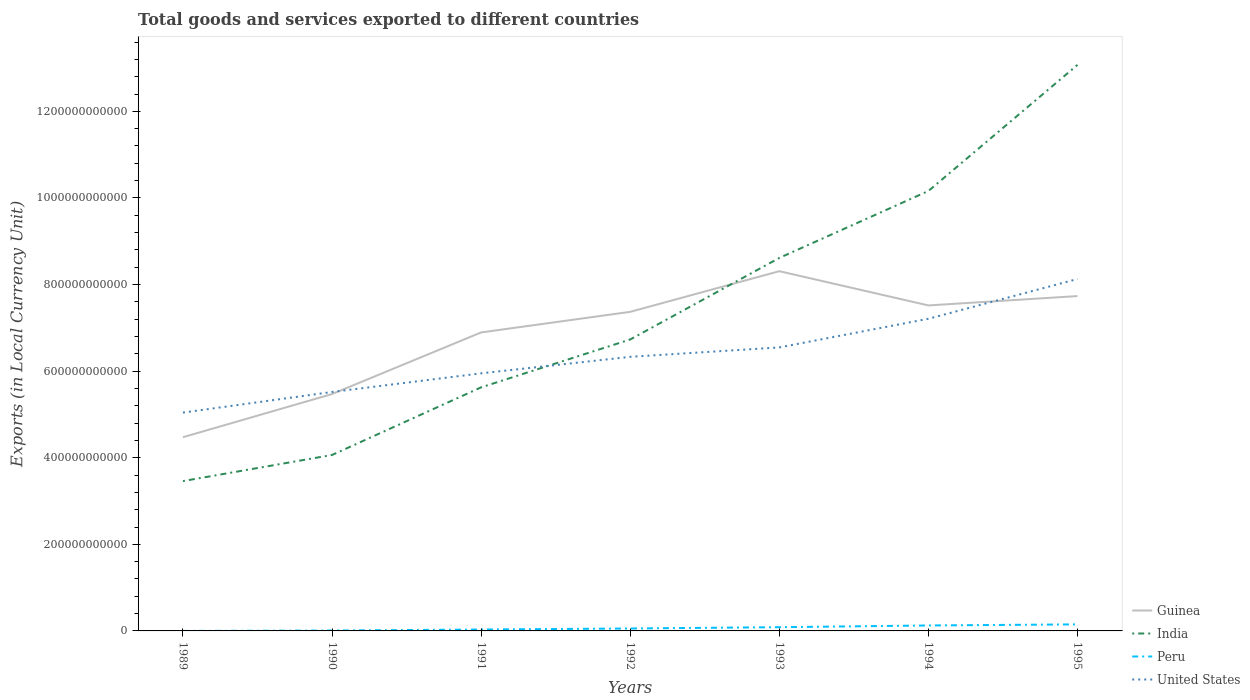How many different coloured lines are there?
Provide a short and direct response. 4. Does the line corresponding to United States intersect with the line corresponding to India?
Offer a very short reply. Yes. Is the number of lines equal to the number of legend labels?
Make the answer very short. Yes. Across all years, what is the maximum Amount of goods and services exports in Guinea?
Offer a terse response. 4.47e+11. What is the total Amount of goods and services exports in Guinea in the graph?
Offer a terse response. -2.26e+11. What is the difference between the highest and the second highest Amount of goods and services exports in India?
Ensure brevity in your answer.  9.61e+11. What is the difference between the highest and the lowest Amount of goods and services exports in Guinea?
Provide a short and direct response. 5. How many lines are there?
Your answer should be very brief. 4. What is the difference between two consecutive major ticks on the Y-axis?
Your answer should be compact. 2.00e+11. How are the legend labels stacked?
Your answer should be very brief. Vertical. What is the title of the graph?
Offer a very short reply. Total goods and services exported to different countries. What is the label or title of the Y-axis?
Provide a succinct answer. Exports (in Local Currency Unit). What is the Exports (in Local Currency Unit) of Guinea in 1989?
Your response must be concise. 4.47e+11. What is the Exports (in Local Currency Unit) of India in 1989?
Your response must be concise. 3.46e+11. What is the Exports (in Local Currency Unit) in Peru in 1989?
Provide a short and direct response. 1.57e+07. What is the Exports (in Local Currency Unit) of United States in 1989?
Your answer should be compact. 5.04e+11. What is the Exports (in Local Currency Unit) in Guinea in 1990?
Provide a short and direct response. 5.47e+11. What is the Exports (in Local Currency Unit) of India in 1990?
Your response must be concise. 4.06e+11. What is the Exports (in Local Currency Unit) of Peru in 1990?
Ensure brevity in your answer.  8.58e+08. What is the Exports (in Local Currency Unit) of United States in 1990?
Give a very brief answer. 5.52e+11. What is the Exports (in Local Currency Unit) of Guinea in 1991?
Your answer should be very brief. 6.89e+11. What is the Exports (in Local Currency Unit) in India in 1991?
Give a very brief answer. 5.63e+11. What is the Exports (in Local Currency Unit) in Peru in 1991?
Your response must be concise. 3.26e+09. What is the Exports (in Local Currency Unit) of United States in 1991?
Keep it short and to the point. 5.95e+11. What is the Exports (in Local Currency Unit) in Guinea in 1992?
Your answer should be compact. 7.37e+11. What is the Exports (in Local Currency Unit) of India in 1992?
Your answer should be compact. 6.73e+11. What is the Exports (in Local Currency Unit) in Peru in 1992?
Give a very brief answer. 5.63e+09. What is the Exports (in Local Currency Unit) in United States in 1992?
Offer a very short reply. 6.33e+11. What is the Exports (in Local Currency Unit) in Guinea in 1993?
Ensure brevity in your answer.  8.31e+11. What is the Exports (in Local Currency Unit) in India in 1993?
Offer a terse response. 8.61e+11. What is the Exports (in Local Currency Unit) in Peru in 1993?
Make the answer very short. 8.63e+09. What is the Exports (in Local Currency Unit) in United States in 1993?
Keep it short and to the point. 6.55e+11. What is the Exports (in Local Currency Unit) of Guinea in 1994?
Offer a terse response. 7.52e+11. What is the Exports (in Local Currency Unit) of India in 1994?
Provide a short and direct response. 1.02e+12. What is the Exports (in Local Currency Unit) of Peru in 1994?
Offer a very short reply. 1.26e+1. What is the Exports (in Local Currency Unit) in United States in 1994?
Make the answer very short. 7.21e+11. What is the Exports (in Local Currency Unit) of Guinea in 1995?
Your response must be concise. 7.73e+11. What is the Exports (in Local Currency Unit) in India in 1995?
Offer a very short reply. 1.31e+12. What is the Exports (in Local Currency Unit) of Peru in 1995?
Give a very brief answer. 1.51e+1. What is the Exports (in Local Currency Unit) of United States in 1995?
Provide a short and direct response. 8.13e+11. Across all years, what is the maximum Exports (in Local Currency Unit) in Guinea?
Your answer should be very brief. 8.31e+11. Across all years, what is the maximum Exports (in Local Currency Unit) of India?
Keep it short and to the point. 1.31e+12. Across all years, what is the maximum Exports (in Local Currency Unit) of Peru?
Your answer should be compact. 1.51e+1. Across all years, what is the maximum Exports (in Local Currency Unit) of United States?
Your answer should be very brief. 8.13e+11. Across all years, what is the minimum Exports (in Local Currency Unit) of Guinea?
Provide a short and direct response. 4.47e+11. Across all years, what is the minimum Exports (in Local Currency Unit) in India?
Provide a short and direct response. 3.46e+11. Across all years, what is the minimum Exports (in Local Currency Unit) in Peru?
Your answer should be compact. 1.57e+07. Across all years, what is the minimum Exports (in Local Currency Unit) of United States?
Your answer should be very brief. 5.04e+11. What is the total Exports (in Local Currency Unit) of Guinea in the graph?
Give a very brief answer. 4.78e+12. What is the total Exports (in Local Currency Unit) in India in the graph?
Provide a short and direct response. 5.17e+12. What is the total Exports (in Local Currency Unit) of Peru in the graph?
Your answer should be compact. 4.61e+1. What is the total Exports (in Local Currency Unit) in United States in the graph?
Provide a succinct answer. 4.47e+12. What is the difference between the Exports (in Local Currency Unit) in Guinea in 1989 and that in 1990?
Make the answer very short. -9.97e+1. What is the difference between the Exports (in Local Currency Unit) of India in 1989 and that in 1990?
Your response must be concise. -6.03e+1. What is the difference between the Exports (in Local Currency Unit) of Peru in 1989 and that in 1990?
Offer a terse response. -8.42e+08. What is the difference between the Exports (in Local Currency Unit) in United States in 1989 and that in 1990?
Provide a succinct answer. -4.76e+1. What is the difference between the Exports (in Local Currency Unit) of Guinea in 1989 and that in 1991?
Provide a short and direct response. -2.42e+11. What is the difference between the Exports (in Local Currency Unit) in India in 1989 and that in 1991?
Your response must be concise. -2.16e+11. What is the difference between the Exports (in Local Currency Unit) of Peru in 1989 and that in 1991?
Give a very brief answer. -3.24e+09. What is the difference between the Exports (in Local Currency Unit) in United States in 1989 and that in 1991?
Your answer should be compact. -9.06e+1. What is the difference between the Exports (in Local Currency Unit) of Guinea in 1989 and that in 1992?
Give a very brief answer. -2.90e+11. What is the difference between the Exports (in Local Currency Unit) in India in 1989 and that in 1992?
Make the answer very short. -3.27e+11. What is the difference between the Exports (in Local Currency Unit) in Peru in 1989 and that in 1992?
Make the answer very short. -5.61e+09. What is the difference between the Exports (in Local Currency Unit) in United States in 1989 and that in 1992?
Ensure brevity in your answer.  -1.29e+11. What is the difference between the Exports (in Local Currency Unit) in Guinea in 1989 and that in 1993?
Your response must be concise. -3.83e+11. What is the difference between the Exports (in Local Currency Unit) in India in 1989 and that in 1993?
Offer a very short reply. -5.15e+11. What is the difference between the Exports (in Local Currency Unit) in Peru in 1989 and that in 1993?
Ensure brevity in your answer.  -8.61e+09. What is the difference between the Exports (in Local Currency Unit) in United States in 1989 and that in 1993?
Make the answer very short. -1.51e+11. What is the difference between the Exports (in Local Currency Unit) in Guinea in 1989 and that in 1994?
Ensure brevity in your answer.  -3.04e+11. What is the difference between the Exports (in Local Currency Unit) of India in 1989 and that in 1994?
Ensure brevity in your answer.  -6.70e+11. What is the difference between the Exports (in Local Currency Unit) in Peru in 1989 and that in 1994?
Keep it short and to the point. -1.26e+1. What is the difference between the Exports (in Local Currency Unit) in United States in 1989 and that in 1994?
Offer a terse response. -2.17e+11. What is the difference between the Exports (in Local Currency Unit) in Guinea in 1989 and that in 1995?
Give a very brief answer. -3.26e+11. What is the difference between the Exports (in Local Currency Unit) of India in 1989 and that in 1995?
Keep it short and to the point. -9.61e+11. What is the difference between the Exports (in Local Currency Unit) in Peru in 1989 and that in 1995?
Ensure brevity in your answer.  -1.51e+1. What is the difference between the Exports (in Local Currency Unit) in United States in 1989 and that in 1995?
Ensure brevity in your answer.  -3.09e+11. What is the difference between the Exports (in Local Currency Unit) in Guinea in 1990 and that in 1991?
Ensure brevity in your answer.  -1.42e+11. What is the difference between the Exports (in Local Currency Unit) in India in 1990 and that in 1991?
Provide a short and direct response. -1.56e+11. What is the difference between the Exports (in Local Currency Unit) in Peru in 1990 and that in 1991?
Your answer should be very brief. -2.40e+09. What is the difference between the Exports (in Local Currency Unit) of United States in 1990 and that in 1991?
Ensure brevity in your answer.  -4.31e+1. What is the difference between the Exports (in Local Currency Unit) of Guinea in 1990 and that in 1992?
Provide a succinct answer. -1.90e+11. What is the difference between the Exports (in Local Currency Unit) of India in 1990 and that in 1992?
Offer a terse response. -2.67e+11. What is the difference between the Exports (in Local Currency Unit) in Peru in 1990 and that in 1992?
Ensure brevity in your answer.  -4.77e+09. What is the difference between the Exports (in Local Currency Unit) of United States in 1990 and that in 1992?
Make the answer very short. -8.12e+1. What is the difference between the Exports (in Local Currency Unit) of Guinea in 1990 and that in 1993?
Keep it short and to the point. -2.84e+11. What is the difference between the Exports (in Local Currency Unit) in India in 1990 and that in 1993?
Your answer should be very brief. -4.55e+11. What is the difference between the Exports (in Local Currency Unit) in Peru in 1990 and that in 1993?
Your answer should be compact. -7.77e+09. What is the difference between the Exports (in Local Currency Unit) of United States in 1990 and that in 1993?
Provide a short and direct response. -1.03e+11. What is the difference between the Exports (in Local Currency Unit) of Guinea in 1990 and that in 1994?
Give a very brief answer. -2.05e+11. What is the difference between the Exports (in Local Currency Unit) in India in 1990 and that in 1994?
Your answer should be compact. -6.10e+11. What is the difference between the Exports (in Local Currency Unit) in Peru in 1990 and that in 1994?
Provide a succinct answer. -1.17e+1. What is the difference between the Exports (in Local Currency Unit) in United States in 1990 and that in 1994?
Offer a terse response. -1.69e+11. What is the difference between the Exports (in Local Currency Unit) of Guinea in 1990 and that in 1995?
Provide a succinct answer. -2.26e+11. What is the difference between the Exports (in Local Currency Unit) of India in 1990 and that in 1995?
Your response must be concise. -9.01e+11. What is the difference between the Exports (in Local Currency Unit) of Peru in 1990 and that in 1995?
Your response must be concise. -1.43e+1. What is the difference between the Exports (in Local Currency Unit) in United States in 1990 and that in 1995?
Your response must be concise. -2.61e+11. What is the difference between the Exports (in Local Currency Unit) of Guinea in 1991 and that in 1992?
Your answer should be very brief. -4.76e+1. What is the difference between the Exports (in Local Currency Unit) in India in 1991 and that in 1992?
Give a very brief answer. -1.11e+11. What is the difference between the Exports (in Local Currency Unit) in Peru in 1991 and that in 1992?
Your response must be concise. -2.37e+09. What is the difference between the Exports (in Local Currency Unit) of United States in 1991 and that in 1992?
Give a very brief answer. -3.81e+1. What is the difference between the Exports (in Local Currency Unit) of Guinea in 1991 and that in 1993?
Give a very brief answer. -1.41e+11. What is the difference between the Exports (in Local Currency Unit) in India in 1991 and that in 1993?
Keep it short and to the point. -2.99e+11. What is the difference between the Exports (in Local Currency Unit) of Peru in 1991 and that in 1993?
Give a very brief answer. -5.37e+09. What is the difference between the Exports (in Local Currency Unit) of United States in 1991 and that in 1993?
Make the answer very short. -5.99e+1. What is the difference between the Exports (in Local Currency Unit) in Guinea in 1991 and that in 1994?
Make the answer very short. -6.24e+1. What is the difference between the Exports (in Local Currency Unit) in India in 1991 and that in 1994?
Your answer should be compact. -4.54e+11. What is the difference between the Exports (in Local Currency Unit) in Peru in 1991 and that in 1994?
Your answer should be very brief. -9.33e+09. What is the difference between the Exports (in Local Currency Unit) in United States in 1991 and that in 1994?
Provide a short and direct response. -1.26e+11. What is the difference between the Exports (in Local Currency Unit) in Guinea in 1991 and that in 1995?
Keep it short and to the point. -8.40e+1. What is the difference between the Exports (in Local Currency Unit) of India in 1991 and that in 1995?
Offer a terse response. -7.45e+11. What is the difference between the Exports (in Local Currency Unit) of Peru in 1991 and that in 1995?
Keep it short and to the point. -1.19e+1. What is the difference between the Exports (in Local Currency Unit) of United States in 1991 and that in 1995?
Your answer should be compact. -2.18e+11. What is the difference between the Exports (in Local Currency Unit) in Guinea in 1992 and that in 1993?
Your answer should be compact. -9.39e+1. What is the difference between the Exports (in Local Currency Unit) in India in 1992 and that in 1993?
Your response must be concise. -1.88e+11. What is the difference between the Exports (in Local Currency Unit) of Peru in 1992 and that in 1993?
Your answer should be very brief. -3.00e+09. What is the difference between the Exports (in Local Currency Unit) in United States in 1992 and that in 1993?
Ensure brevity in your answer.  -2.17e+1. What is the difference between the Exports (in Local Currency Unit) of Guinea in 1992 and that in 1994?
Your response must be concise. -1.48e+1. What is the difference between the Exports (in Local Currency Unit) in India in 1992 and that in 1994?
Provide a succinct answer. -3.43e+11. What is the difference between the Exports (in Local Currency Unit) of Peru in 1992 and that in 1994?
Offer a very short reply. -6.96e+09. What is the difference between the Exports (in Local Currency Unit) of United States in 1992 and that in 1994?
Make the answer very short. -8.79e+1. What is the difference between the Exports (in Local Currency Unit) in Guinea in 1992 and that in 1995?
Provide a succinct answer. -3.64e+1. What is the difference between the Exports (in Local Currency Unit) in India in 1992 and that in 1995?
Your answer should be compact. -6.34e+11. What is the difference between the Exports (in Local Currency Unit) in Peru in 1992 and that in 1995?
Provide a short and direct response. -9.49e+09. What is the difference between the Exports (in Local Currency Unit) in United States in 1992 and that in 1995?
Give a very brief answer. -1.80e+11. What is the difference between the Exports (in Local Currency Unit) in Guinea in 1993 and that in 1994?
Make the answer very short. 7.91e+1. What is the difference between the Exports (in Local Currency Unit) of India in 1993 and that in 1994?
Ensure brevity in your answer.  -1.55e+11. What is the difference between the Exports (in Local Currency Unit) in Peru in 1993 and that in 1994?
Your answer should be compact. -3.96e+09. What is the difference between the Exports (in Local Currency Unit) of United States in 1993 and that in 1994?
Your answer should be compact. -6.61e+1. What is the difference between the Exports (in Local Currency Unit) in Guinea in 1993 and that in 1995?
Provide a short and direct response. 5.75e+1. What is the difference between the Exports (in Local Currency Unit) in India in 1993 and that in 1995?
Your answer should be compact. -4.46e+11. What is the difference between the Exports (in Local Currency Unit) of Peru in 1993 and that in 1995?
Provide a short and direct response. -6.49e+09. What is the difference between the Exports (in Local Currency Unit) of United States in 1993 and that in 1995?
Your response must be concise. -1.58e+11. What is the difference between the Exports (in Local Currency Unit) in Guinea in 1994 and that in 1995?
Provide a succinct answer. -2.16e+1. What is the difference between the Exports (in Local Currency Unit) in India in 1994 and that in 1995?
Offer a terse response. -2.91e+11. What is the difference between the Exports (in Local Currency Unit) in Peru in 1994 and that in 1995?
Ensure brevity in your answer.  -2.53e+09. What is the difference between the Exports (in Local Currency Unit) in United States in 1994 and that in 1995?
Ensure brevity in your answer.  -9.19e+1. What is the difference between the Exports (in Local Currency Unit) in Guinea in 1989 and the Exports (in Local Currency Unit) in India in 1990?
Provide a short and direct response. 4.11e+1. What is the difference between the Exports (in Local Currency Unit) in Guinea in 1989 and the Exports (in Local Currency Unit) in Peru in 1990?
Make the answer very short. 4.47e+11. What is the difference between the Exports (in Local Currency Unit) of Guinea in 1989 and the Exports (in Local Currency Unit) of United States in 1990?
Offer a very short reply. -1.04e+11. What is the difference between the Exports (in Local Currency Unit) of India in 1989 and the Exports (in Local Currency Unit) of Peru in 1990?
Ensure brevity in your answer.  3.45e+11. What is the difference between the Exports (in Local Currency Unit) in India in 1989 and the Exports (in Local Currency Unit) in United States in 1990?
Ensure brevity in your answer.  -2.06e+11. What is the difference between the Exports (in Local Currency Unit) of Peru in 1989 and the Exports (in Local Currency Unit) of United States in 1990?
Offer a terse response. -5.52e+11. What is the difference between the Exports (in Local Currency Unit) in Guinea in 1989 and the Exports (in Local Currency Unit) in India in 1991?
Your answer should be compact. -1.15e+11. What is the difference between the Exports (in Local Currency Unit) of Guinea in 1989 and the Exports (in Local Currency Unit) of Peru in 1991?
Your response must be concise. 4.44e+11. What is the difference between the Exports (in Local Currency Unit) of Guinea in 1989 and the Exports (in Local Currency Unit) of United States in 1991?
Your response must be concise. -1.48e+11. What is the difference between the Exports (in Local Currency Unit) of India in 1989 and the Exports (in Local Currency Unit) of Peru in 1991?
Make the answer very short. 3.43e+11. What is the difference between the Exports (in Local Currency Unit) in India in 1989 and the Exports (in Local Currency Unit) in United States in 1991?
Offer a terse response. -2.49e+11. What is the difference between the Exports (in Local Currency Unit) of Peru in 1989 and the Exports (in Local Currency Unit) of United States in 1991?
Ensure brevity in your answer.  -5.95e+11. What is the difference between the Exports (in Local Currency Unit) of Guinea in 1989 and the Exports (in Local Currency Unit) of India in 1992?
Your answer should be compact. -2.26e+11. What is the difference between the Exports (in Local Currency Unit) of Guinea in 1989 and the Exports (in Local Currency Unit) of Peru in 1992?
Ensure brevity in your answer.  4.42e+11. What is the difference between the Exports (in Local Currency Unit) in Guinea in 1989 and the Exports (in Local Currency Unit) in United States in 1992?
Your answer should be very brief. -1.86e+11. What is the difference between the Exports (in Local Currency Unit) in India in 1989 and the Exports (in Local Currency Unit) in Peru in 1992?
Your answer should be very brief. 3.40e+11. What is the difference between the Exports (in Local Currency Unit) in India in 1989 and the Exports (in Local Currency Unit) in United States in 1992?
Offer a terse response. -2.87e+11. What is the difference between the Exports (in Local Currency Unit) of Peru in 1989 and the Exports (in Local Currency Unit) of United States in 1992?
Your response must be concise. -6.33e+11. What is the difference between the Exports (in Local Currency Unit) of Guinea in 1989 and the Exports (in Local Currency Unit) of India in 1993?
Provide a succinct answer. -4.14e+11. What is the difference between the Exports (in Local Currency Unit) of Guinea in 1989 and the Exports (in Local Currency Unit) of Peru in 1993?
Your answer should be compact. 4.39e+11. What is the difference between the Exports (in Local Currency Unit) of Guinea in 1989 and the Exports (in Local Currency Unit) of United States in 1993?
Your answer should be very brief. -2.07e+11. What is the difference between the Exports (in Local Currency Unit) in India in 1989 and the Exports (in Local Currency Unit) in Peru in 1993?
Offer a terse response. 3.37e+11. What is the difference between the Exports (in Local Currency Unit) in India in 1989 and the Exports (in Local Currency Unit) in United States in 1993?
Keep it short and to the point. -3.09e+11. What is the difference between the Exports (in Local Currency Unit) of Peru in 1989 and the Exports (in Local Currency Unit) of United States in 1993?
Ensure brevity in your answer.  -6.55e+11. What is the difference between the Exports (in Local Currency Unit) of Guinea in 1989 and the Exports (in Local Currency Unit) of India in 1994?
Keep it short and to the point. -5.69e+11. What is the difference between the Exports (in Local Currency Unit) of Guinea in 1989 and the Exports (in Local Currency Unit) of Peru in 1994?
Provide a succinct answer. 4.35e+11. What is the difference between the Exports (in Local Currency Unit) in Guinea in 1989 and the Exports (in Local Currency Unit) in United States in 1994?
Provide a short and direct response. -2.74e+11. What is the difference between the Exports (in Local Currency Unit) of India in 1989 and the Exports (in Local Currency Unit) of Peru in 1994?
Provide a short and direct response. 3.33e+11. What is the difference between the Exports (in Local Currency Unit) of India in 1989 and the Exports (in Local Currency Unit) of United States in 1994?
Give a very brief answer. -3.75e+11. What is the difference between the Exports (in Local Currency Unit) of Peru in 1989 and the Exports (in Local Currency Unit) of United States in 1994?
Your answer should be very brief. -7.21e+11. What is the difference between the Exports (in Local Currency Unit) in Guinea in 1989 and the Exports (in Local Currency Unit) in India in 1995?
Provide a short and direct response. -8.60e+11. What is the difference between the Exports (in Local Currency Unit) in Guinea in 1989 and the Exports (in Local Currency Unit) in Peru in 1995?
Ensure brevity in your answer.  4.32e+11. What is the difference between the Exports (in Local Currency Unit) in Guinea in 1989 and the Exports (in Local Currency Unit) in United States in 1995?
Offer a terse response. -3.65e+11. What is the difference between the Exports (in Local Currency Unit) of India in 1989 and the Exports (in Local Currency Unit) of Peru in 1995?
Your response must be concise. 3.31e+11. What is the difference between the Exports (in Local Currency Unit) in India in 1989 and the Exports (in Local Currency Unit) in United States in 1995?
Provide a succinct answer. -4.67e+11. What is the difference between the Exports (in Local Currency Unit) of Peru in 1989 and the Exports (in Local Currency Unit) of United States in 1995?
Give a very brief answer. -8.13e+11. What is the difference between the Exports (in Local Currency Unit) of Guinea in 1990 and the Exports (in Local Currency Unit) of India in 1991?
Keep it short and to the point. -1.55e+1. What is the difference between the Exports (in Local Currency Unit) of Guinea in 1990 and the Exports (in Local Currency Unit) of Peru in 1991?
Provide a succinct answer. 5.44e+11. What is the difference between the Exports (in Local Currency Unit) of Guinea in 1990 and the Exports (in Local Currency Unit) of United States in 1991?
Provide a succinct answer. -4.79e+1. What is the difference between the Exports (in Local Currency Unit) of India in 1990 and the Exports (in Local Currency Unit) of Peru in 1991?
Provide a succinct answer. 4.03e+11. What is the difference between the Exports (in Local Currency Unit) in India in 1990 and the Exports (in Local Currency Unit) in United States in 1991?
Offer a terse response. -1.89e+11. What is the difference between the Exports (in Local Currency Unit) in Peru in 1990 and the Exports (in Local Currency Unit) in United States in 1991?
Keep it short and to the point. -5.94e+11. What is the difference between the Exports (in Local Currency Unit) of Guinea in 1990 and the Exports (in Local Currency Unit) of India in 1992?
Give a very brief answer. -1.26e+11. What is the difference between the Exports (in Local Currency Unit) in Guinea in 1990 and the Exports (in Local Currency Unit) in Peru in 1992?
Make the answer very short. 5.41e+11. What is the difference between the Exports (in Local Currency Unit) in Guinea in 1990 and the Exports (in Local Currency Unit) in United States in 1992?
Offer a terse response. -8.60e+1. What is the difference between the Exports (in Local Currency Unit) in India in 1990 and the Exports (in Local Currency Unit) in Peru in 1992?
Ensure brevity in your answer.  4.01e+11. What is the difference between the Exports (in Local Currency Unit) of India in 1990 and the Exports (in Local Currency Unit) of United States in 1992?
Your answer should be compact. -2.27e+11. What is the difference between the Exports (in Local Currency Unit) of Peru in 1990 and the Exports (in Local Currency Unit) of United States in 1992?
Provide a short and direct response. -6.32e+11. What is the difference between the Exports (in Local Currency Unit) in Guinea in 1990 and the Exports (in Local Currency Unit) in India in 1993?
Keep it short and to the point. -3.14e+11. What is the difference between the Exports (in Local Currency Unit) in Guinea in 1990 and the Exports (in Local Currency Unit) in Peru in 1993?
Make the answer very short. 5.38e+11. What is the difference between the Exports (in Local Currency Unit) of Guinea in 1990 and the Exports (in Local Currency Unit) of United States in 1993?
Provide a short and direct response. -1.08e+11. What is the difference between the Exports (in Local Currency Unit) in India in 1990 and the Exports (in Local Currency Unit) in Peru in 1993?
Keep it short and to the point. 3.98e+11. What is the difference between the Exports (in Local Currency Unit) in India in 1990 and the Exports (in Local Currency Unit) in United States in 1993?
Keep it short and to the point. -2.48e+11. What is the difference between the Exports (in Local Currency Unit) of Peru in 1990 and the Exports (in Local Currency Unit) of United States in 1993?
Provide a succinct answer. -6.54e+11. What is the difference between the Exports (in Local Currency Unit) in Guinea in 1990 and the Exports (in Local Currency Unit) in India in 1994?
Your answer should be compact. -4.69e+11. What is the difference between the Exports (in Local Currency Unit) in Guinea in 1990 and the Exports (in Local Currency Unit) in Peru in 1994?
Your answer should be compact. 5.34e+11. What is the difference between the Exports (in Local Currency Unit) in Guinea in 1990 and the Exports (in Local Currency Unit) in United States in 1994?
Offer a very short reply. -1.74e+11. What is the difference between the Exports (in Local Currency Unit) in India in 1990 and the Exports (in Local Currency Unit) in Peru in 1994?
Give a very brief answer. 3.94e+11. What is the difference between the Exports (in Local Currency Unit) in India in 1990 and the Exports (in Local Currency Unit) in United States in 1994?
Give a very brief answer. -3.15e+11. What is the difference between the Exports (in Local Currency Unit) in Peru in 1990 and the Exports (in Local Currency Unit) in United States in 1994?
Give a very brief answer. -7.20e+11. What is the difference between the Exports (in Local Currency Unit) of Guinea in 1990 and the Exports (in Local Currency Unit) of India in 1995?
Provide a short and direct response. -7.60e+11. What is the difference between the Exports (in Local Currency Unit) of Guinea in 1990 and the Exports (in Local Currency Unit) of Peru in 1995?
Give a very brief answer. 5.32e+11. What is the difference between the Exports (in Local Currency Unit) in Guinea in 1990 and the Exports (in Local Currency Unit) in United States in 1995?
Make the answer very short. -2.66e+11. What is the difference between the Exports (in Local Currency Unit) in India in 1990 and the Exports (in Local Currency Unit) in Peru in 1995?
Your response must be concise. 3.91e+11. What is the difference between the Exports (in Local Currency Unit) of India in 1990 and the Exports (in Local Currency Unit) of United States in 1995?
Provide a succinct answer. -4.06e+11. What is the difference between the Exports (in Local Currency Unit) in Peru in 1990 and the Exports (in Local Currency Unit) in United States in 1995?
Your answer should be very brief. -8.12e+11. What is the difference between the Exports (in Local Currency Unit) of Guinea in 1991 and the Exports (in Local Currency Unit) of India in 1992?
Offer a terse response. 1.63e+1. What is the difference between the Exports (in Local Currency Unit) of Guinea in 1991 and the Exports (in Local Currency Unit) of Peru in 1992?
Your answer should be compact. 6.84e+11. What is the difference between the Exports (in Local Currency Unit) in Guinea in 1991 and the Exports (in Local Currency Unit) in United States in 1992?
Your answer should be very brief. 5.63e+1. What is the difference between the Exports (in Local Currency Unit) in India in 1991 and the Exports (in Local Currency Unit) in Peru in 1992?
Give a very brief answer. 5.57e+11. What is the difference between the Exports (in Local Currency Unit) in India in 1991 and the Exports (in Local Currency Unit) in United States in 1992?
Offer a very short reply. -7.05e+1. What is the difference between the Exports (in Local Currency Unit) of Peru in 1991 and the Exports (in Local Currency Unit) of United States in 1992?
Your answer should be compact. -6.30e+11. What is the difference between the Exports (in Local Currency Unit) of Guinea in 1991 and the Exports (in Local Currency Unit) of India in 1993?
Your response must be concise. -1.72e+11. What is the difference between the Exports (in Local Currency Unit) in Guinea in 1991 and the Exports (in Local Currency Unit) in Peru in 1993?
Your response must be concise. 6.81e+11. What is the difference between the Exports (in Local Currency Unit) of Guinea in 1991 and the Exports (in Local Currency Unit) of United States in 1993?
Make the answer very short. 3.46e+1. What is the difference between the Exports (in Local Currency Unit) of India in 1991 and the Exports (in Local Currency Unit) of Peru in 1993?
Make the answer very short. 5.54e+11. What is the difference between the Exports (in Local Currency Unit) of India in 1991 and the Exports (in Local Currency Unit) of United States in 1993?
Give a very brief answer. -9.23e+1. What is the difference between the Exports (in Local Currency Unit) in Peru in 1991 and the Exports (in Local Currency Unit) in United States in 1993?
Give a very brief answer. -6.52e+11. What is the difference between the Exports (in Local Currency Unit) in Guinea in 1991 and the Exports (in Local Currency Unit) in India in 1994?
Provide a short and direct response. -3.27e+11. What is the difference between the Exports (in Local Currency Unit) of Guinea in 1991 and the Exports (in Local Currency Unit) of Peru in 1994?
Offer a terse response. 6.77e+11. What is the difference between the Exports (in Local Currency Unit) of Guinea in 1991 and the Exports (in Local Currency Unit) of United States in 1994?
Provide a short and direct response. -3.15e+1. What is the difference between the Exports (in Local Currency Unit) in India in 1991 and the Exports (in Local Currency Unit) in Peru in 1994?
Provide a short and direct response. 5.50e+11. What is the difference between the Exports (in Local Currency Unit) in India in 1991 and the Exports (in Local Currency Unit) in United States in 1994?
Your answer should be very brief. -1.58e+11. What is the difference between the Exports (in Local Currency Unit) of Peru in 1991 and the Exports (in Local Currency Unit) of United States in 1994?
Your response must be concise. -7.18e+11. What is the difference between the Exports (in Local Currency Unit) of Guinea in 1991 and the Exports (in Local Currency Unit) of India in 1995?
Give a very brief answer. -6.18e+11. What is the difference between the Exports (in Local Currency Unit) in Guinea in 1991 and the Exports (in Local Currency Unit) in Peru in 1995?
Ensure brevity in your answer.  6.74e+11. What is the difference between the Exports (in Local Currency Unit) in Guinea in 1991 and the Exports (in Local Currency Unit) in United States in 1995?
Your answer should be compact. -1.23e+11. What is the difference between the Exports (in Local Currency Unit) of India in 1991 and the Exports (in Local Currency Unit) of Peru in 1995?
Offer a terse response. 5.47e+11. What is the difference between the Exports (in Local Currency Unit) of India in 1991 and the Exports (in Local Currency Unit) of United States in 1995?
Give a very brief answer. -2.50e+11. What is the difference between the Exports (in Local Currency Unit) of Peru in 1991 and the Exports (in Local Currency Unit) of United States in 1995?
Your answer should be very brief. -8.10e+11. What is the difference between the Exports (in Local Currency Unit) of Guinea in 1992 and the Exports (in Local Currency Unit) of India in 1993?
Your response must be concise. -1.25e+11. What is the difference between the Exports (in Local Currency Unit) in Guinea in 1992 and the Exports (in Local Currency Unit) in Peru in 1993?
Offer a terse response. 7.28e+11. What is the difference between the Exports (in Local Currency Unit) of Guinea in 1992 and the Exports (in Local Currency Unit) of United States in 1993?
Your answer should be compact. 8.22e+1. What is the difference between the Exports (in Local Currency Unit) in India in 1992 and the Exports (in Local Currency Unit) in Peru in 1993?
Provide a succinct answer. 6.64e+11. What is the difference between the Exports (in Local Currency Unit) in India in 1992 and the Exports (in Local Currency Unit) in United States in 1993?
Provide a short and direct response. 1.83e+1. What is the difference between the Exports (in Local Currency Unit) in Peru in 1992 and the Exports (in Local Currency Unit) in United States in 1993?
Offer a very short reply. -6.49e+11. What is the difference between the Exports (in Local Currency Unit) in Guinea in 1992 and the Exports (in Local Currency Unit) in India in 1994?
Keep it short and to the point. -2.79e+11. What is the difference between the Exports (in Local Currency Unit) in Guinea in 1992 and the Exports (in Local Currency Unit) in Peru in 1994?
Offer a terse response. 7.24e+11. What is the difference between the Exports (in Local Currency Unit) in Guinea in 1992 and the Exports (in Local Currency Unit) in United States in 1994?
Keep it short and to the point. 1.60e+1. What is the difference between the Exports (in Local Currency Unit) of India in 1992 and the Exports (in Local Currency Unit) of Peru in 1994?
Make the answer very short. 6.61e+11. What is the difference between the Exports (in Local Currency Unit) in India in 1992 and the Exports (in Local Currency Unit) in United States in 1994?
Your response must be concise. -4.78e+1. What is the difference between the Exports (in Local Currency Unit) in Peru in 1992 and the Exports (in Local Currency Unit) in United States in 1994?
Keep it short and to the point. -7.15e+11. What is the difference between the Exports (in Local Currency Unit) of Guinea in 1992 and the Exports (in Local Currency Unit) of India in 1995?
Your answer should be very brief. -5.70e+11. What is the difference between the Exports (in Local Currency Unit) in Guinea in 1992 and the Exports (in Local Currency Unit) in Peru in 1995?
Ensure brevity in your answer.  7.22e+11. What is the difference between the Exports (in Local Currency Unit) in Guinea in 1992 and the Exports (in Local Currency Unit) in United States in 1995?
Offer a very short reply. -7.58e+1. What is the difference between the Exports (in Local Currency Unit) of India in 1992 and the Exports (in Local Currency Unit) of Peru in 1995?
Give a very brief answer. 6.58e+11. What is the difference between the Exports (in Local Currency Unit) in India in 1992 and the Exports (in Local Currency Unit) in United States in 1995?
Provide a short and direct response. -1.40e+11. What is the difference between the Exports (in Local Currency Unit) in Peru in 1992 and the Exports (in Local Currency Unit) in United States in 1995?
Ensure brevity in your answer.  -8.07e+11. What is the difference between the Exports (in Local Currency Unit) of Guinea in 1993 and the Exports (in Local Currency Unit) of India in 1994?
Ensure brevity in your answer.  -1.85e+11. What is the difference between the Exports (in Local Currency Unit) of Guinea in 1993 and the Exports (in Local Currency Unit) of Peru in 1994?
Ensure brevity in your answer.  8.18e+11. What is the difference between the Exports (in Local Currency Unit) in Guinea in 1993 and the Exports (in Local Currency Unit) in United States in 1994?
Give a very brief answer. 1.10e+11. What is the difference between the Exports (in Local Currency Unit) in India in 1993 and the Exports (in Local Currency Unit) in Peru in 1994?
Provide a succinct answer. 8.49e+11. What is the difference between the Exports (in Local Currency Unit) in India in 1993 and the Exports (in Local Currency Unit) in United States in 1994?
Keep it short and to the point. 1.41e+11. What is the difference between the Exports (in Local Currency Unit) in Peru in 1993 and the Exports (in Local Currency Unit) in United States in 1994?
Your response must be concise. -7.12e+11. What is the difference between the Exports (in Local Currency Unit) of Guinea in 1993 and the Exports (in Local Currency Unit) of India in 1995?
Your answer should be compact. -4.76e+11. What is the difference between the Exports (in Local Currency Unit) in Guinea in 1993 and the Exports (in Local Currency Unit) in Peru in 1995?
Your answer should be very brief. 8.16e+11. What is the difference between the Exports (in Local Currency Unit) in Guinea in 1993 and the Exports (in Local Currency Unit) in United States in 1995?
Provide a short and direct response. 1.80e+1. What is the difference between the Exports (in Local Currency Unit) of India in 1993 and the Exports (in Local Currency Unit) of Peru in 1995?
Keep it short and to the point. 8.46e+11. What is the difference between the Exports (in Local Currency Unit) of India in 1993 and the Exports (in Local Currency Unit) of United States in 1995?
Make the answer very short. 4.87e+1. What is the difference between the Exports (in Local Currency Unit) in Peru in 1993 and the Exports (in Local Currency Unit) in United States in 1995?
Provide a succinct answer. -8.04e+11. What is the difference between the Exports (in Local Currency Unit) of Guinea in 1994 and the Exports (in Local Currency Unit) of India in 1995?
Ensure brevity in your answer.  -5.56e+11. What is the difference between the Exports (in Local Currency Unit) in Guinea in 1994 and the Exports (in Local Currency Unit) in Peru in 1995?
Offer a terse response. 7.37e+11. What is the difference between the Exports (in Local Currency Unit) in Guinea in 1994 and the Exports (in Local Currency Unit) in United States in 1995?
Make the answer very short. -6.11e+1. What is the difference between the Exports (in Local Currency Unit) in India in 1994 and the Exports (in Local Currency Unit) in Peru in 1995?
Your answer should be very brief. 1.00e+12. What is the difference between the Exports (in Local Currency Unit) of India in 1994 and the Exports (in Local Currency Unit) of United States in 1995?
Provide a short and direct response. 2.03e+11. What is the difference between the Exports (in Local Currency Unit) in Peru in 1994 and the Exports (in Local Currency Unit) in United States in 1995?
Your answer should be compact. -8.00e+11. What is the average Exports (in Local Currency Unit) in Guinea per year?
Give a very brief answer. 6.82e+11. What is the average Exports (in Local Currency Unit) in India per year?
Offer a very short reply. 7.39e+11. What is the average Exports (in Local Currency Unit) of Peru per year?
Offer a terse response. 6.59e+09. What is the average Exports (in Local Currency Unit) in United States per year?
Make the answer very short. 6.39e+11. In the year 1989, what is the difference between the Exports (in Local Currency Unit) of Guinea and Exports (in Local Currency Unit) of India?
Provide a short and direct response. 1.01e+11. In the year 1989, what is the difference between the Exports (in Local Currency Unit) of Guinea and Exports (in Local Currency Unit) of Peru?
Your answer should be very brief. 4.47e+11. In the year 1989, what is the difference between the Exports (in Local Currency Unit) of Guinea and Exports (in Local Currency Unit) of United States?
Make the answer very short. -5.69e+1. In the year 1989, what is the difference between the Exports (in Local Currency Unit) of India and Exports (in Local Currency Unit) of Peru?
Your response must be concise. 3.46e+11. In the year 1989, what is the difference between the Exports (in Local Currency Unit) of India and Exports (in Local Currency Unit) of United States?
Offer a terse response. -1.58e+11. In the year 1989, what is the difference between the Exports (in Local Currency Unit) of Peru and Exports (in Local Currency Unit) of United States?
Provide a succinct answer. -5.04e+11. In the year 1990, what is the difference between the Exports (in Local Currency Unit) of Guinea and Exports (in Local Currency Unit) of India?
Make the answer very short. 1.41e+11. In the year 1990, what is the difference between the Exports (in Local Currency Unit) in Guinea and Exports (in Local Currency Unit) in Peru?
Offer a terse response. 5.46e+11. In the year 1990, what is the difference between the Exports (in Local Currency Unit) in Guinea and Exports (in Local Currency Unit) in United States?
Give a very brief answer. -4.79e+09. In the year 1990, what is the difference between the Exports (in Local Currency Unit) in India and Exports (in Local Currency Unit) in Peru?
Give a very brief answer. 4.05e+11. In the year 1990, what is the difference between the Exports (in Local Currency Unit) in India and Exports (in Local Currency Unit) in United States?
Provide a short and direct response. -1.46e+11. In the year 1990, what is the difference between the Exports (in Local Currency Unit) in Peru and Exports (in Local Currency Unit) in United States?
Your response must be concise. -5.51e+11. In the year 1991, what is the difference between the Exports (in Local Currency Unit) in Guinea and Exports (in Local Currency Unit) in India?
Make the answer very short. 1.27e+11. In the year 1991, what is the difference between the Exports (in Local Currency Unit) of Guinea and Exports (in Local Currency Unit) of Peru?
Your answer should be compact. 6.86e+11. In the year 1991, what is the difference between the Exports (in Local Currency Unit) of Guinea and Exports (in Local Currency Unit) of United States?
Provide a succinct answer. 9.45e+1. In the year 1991, what is the difference between the Exports (in Local Currency Unit) in India and Exports (in Local Currency Unit) in Peru?
Provide a short and direct response. 5.59e+11. In the year 1991, what is the difference between the Exports (in Local Currency Unit) in India and Exports (in Local Currency Unit) in United States?
Your response must be concise. -3.24e+1. In the year 1991, what is the difference between the Exports (in Local Currency Unit) in Peru and Exports (in Local Currency Unit) in United States?
Ensure brevity in your answer.  -5.92e+11. In the year 1992, what is the difference between the Exports (in Local Currency Unit) of Guinea and Exports (in Local Currency Unit) of India?
Ensure brevity in your answer.  6.38e+1. In the year 1992, what is the difference between the Exports (in Local Currency Unit) of Guinea and Exports (in Local Currency Unit) of Peru?
Provide a short and direct response. 7.31e+11. In the year 1992, what is the difference between the Exports (in Local Currency Unit) of Guinea and Exports (in Local Currency Unit) of United States?
Your response must be concise. 1.04e+11. In the year 1992, what is the difference between the Exports (in Local Currency Unit) in India and Exports (in Local Currency Unit) in Peru?
Make the answer very short. 6.67e+11. In the year 1992, what is the difference between the Exports (in Local Currency Unit) of India and Exports (in Local Currency Unit) of United States?
Make the answer very short. 4.01e+1. In the year 1992, what is the difference between the Exports (in Local Currency Unit) in Peru and Exports (in Local Currency Unit) in United States?
Your answer should be very brief. -6.27e+11. In the year 1993, what is the difference between the Exports (in Local Currency Unit) in Guinea and Exports (in Local Currency Unit) in India?
Ensure brevity in your answer.  -3.06e+1. In the year 1993, what is the difference between the Exports (in Local Currency Unit) of Guinea and Exports (in Local Currency Unit) of Peru?
Your answer should be very brief. 8.22e+11. In the year 1993, what is the difference between the Exports (in Local Currency Unit) of Guinea and Exports (in Local Currency Unit) of United States?
Your answer should be compact. 1.76e+11. In the year 1993, what is the difference between the Exports (in Local Currency Unit) of India and Exports (in Local Currency Unit) of Peru?
Offer a terse response. 8.53e+11. In the year 1993, what is the difference between the Exports (in Local Currency Unit) in India and Exports (in Local Currency Unit) in United States?
Provide a short and direct response. 2.07e+11. In the year 1993, what is the difference between the Exports (in Local Currency Unit) in Peru and Exports (in Local Currency Unit) in United States?
Offer a terse response. -6.46e+11. In the year 1994, what is the difference between the Exports (in Local Currency Unit) of Guinea and Exports (in Local Currency Unit) of India?
Offer a very short reply. -2.64e+11. In the year 1994, what is the difference between the Exports (in Local Currency Unit) in Guinea and Exports (in Local Currency Unit) in Peru?
Offer a very short reply. 7.39e+11. In the year 1994, what is the difference between the Exports (in Local Currency Unit) of Guinea and Exports (in Local Currency Unit) of United States?
Offer a very short reply. 3.08e+1. In the year 1994, what is the difference between the Exports (in Local Currency Unit) of India and Exports (in Local Currency Unit) of Peru?
Your answer should be compact. 1.00e+12. In the year 1994, what is the difference between the Exports (in Local Currency Unit) in India and Exports (in Local Currency Unit) in United States?
Your answer should be very brief. 2.95e+11. In the year 1994, what is the difference between the Exports (in Local Currency Unit) of Peru and Exports (in Local Currency Unit) of United States?
Your response must be concise. -7.08e+11. In the year 1995, what is the difference between the Exports (in Local Currency Unit) in Guinea and Exports (in Local Currency Unit) in India?
Your answer should be compact. -5.34e+11. In the year 1995, what is the difference between the Exports (in Local Currency Unit) of Guinea and Exports (in Local Currency Unit) of Peru?
Your response must be concise. 7.58e+11. In the year 1995, what is the difference between the Exports (in Local Currency Unit) in Guinea and Exports (in Local Currency Unit) in United States?
Ensure brevity in your answer.  -3.94e+1. In the year 1995, what is the difference between the Exports (in Local Currency Unit) of India and Exports (in Local Currency Unit) of Peru?
Keep it short and to the point. 1.29e+12. In the year 1995, what is the difference between the Exports (in Local Currency Unit) of India and Exports (in Local Currency Unit) of United States?
Offer a very short reply. 4.95e+11. In the year 1995, what is the difference between the Exports (in Local Currency Unit) of Peru and Exports (in Local Currency Unit) of United States?
Your answer should be compact. -7.98e+11. What is the ratio of the Exports (in Local Currency Unit) in Guinea in 1989 to that in 1990?
Give a very brief answer. 0.82. What is the ratio of the Exports (in Local Currency Unit) in India in 1989 to that in 1990?
Provide a succinct answer. 0.85. What is the ratio of the Exports (in Local Currency Unit) of Peru in 1989 to that in 1990?
Offer a terse response. 0.02. What is the ratio of the Exports (in Local Currency Unit) of United States in 1989 to that in 1990?
Offer a terse response. 0.91. What is the ratio of the Exports (in Local Currency Unit) of Guinea in 1989 to that in 1991?
Offer a very short reply. 0.65. What is the ratio of the Exports (in Local Currency Unit) in India in 1989 to that in 1991?
Provide a succinct answer. 0.62. What is the ratio of the Exports (in Local Currency Unit) of Peru in 1989 to that in 1991?
Provide a succinct answer. 0. What is the ratio of the Exports (in Local Currency Unit) in United States in 1989 to that in 1991?
Keep it short and to the point. 0.85. What is the ratio of the Exports (in Local Currency Unit) in Guinea in 1989 to that in 1992?
Make the answer very short. 0.61. What is the ratio of the Exports (in Local Currency Unit) in India in 1989 to that in 1992?
Ensure brevity in your answer.  0.51. What is the ratio of the Exports (in Local Currency Unit) in Peru in 1989 to that in 1992?
Make the answer very short. 0. What is the ratio of the Exports (in Local Currency Unit) in United States in 1989 to that in 1992?
Keep it short and to the point. 0.8. What is the ratio of the Exports (in Local Currency Unit) in Guinea in 1989 to that in 1993?
Provide a succinct answer. 0.54. What is the ratio of the Exports (in Local Currency Unit) of India in 1989 to that in 1993?
Provide a short and direct response. 0.4. What is the ratio of the Exports (in Local Currency Unit) in Peru in 1989 to that in 1993?
Provide a succinct answer. 0. What is the ratio of the Exports (in Local Currency Unit) in United States in 1989 to that in 1993?
Ensure brevity in your answer.  0.77. What is the ratio of the Exports (in Local Currency Unit) of Guinea in 1989 to that in 1994?
Your answer should be very brief. 0.6. What is the ratio of the Exports (in Local Currency Unit) of India in 1989 to that in 1994?
Make the answer very short. 0.34. What is the ratio of the Exports (in Local Currency Unit) of Peru in 1989 to that in 1994?
Your answer should be compact. 0. What is the ratio of the Exports (in Local Currency Unit) of United States in 1989 to that in 1994?
Give a very brief answer. 0.7. What is the ratio of the Exports (in Local Currency Unit) in Guinea in 1989 to that in 1995?
Your response must be concise. 0.58. What is the ratio of the Exports (in Local Currency Unit) in India in 1989 to that in 1995?
Make the answer very short. 0.26. What is the ratio of the Exports (in Local Currency Unit) of Peru in 1989 to that in 1995?
Your response must be concise. 0. What is the ratio of the Exports (in Local Currency Unit) in United States in 1989 to that in 1995?
Keep it short and to the point. 0.62. What is the ratio of the Exports (in Local Currency Unit) in Guinea in 1990 to that in 1991?
Make the answer very short. 0.79. What is the ratio of the Exports (in Local Currency Unit) in India in 1990 to that in 1991?
Provide a succinct answer. 0.72. What is the ratio of the Exports (in Local Currency Unit) in Peru in 1990 to that in 1991?
Ensure brevity in your answer.  0.26. What is the ratio of the Exports (in Local Currency Unit) in United States in 1990 to that in 1991?
Your response must be concise. 0.93. What is the ratio of the Exports (in Local Currency Unit) in Guinea in 1990 to that in 1992?
Ensure brevity in your answer.  0.74. What is the ratio of the Exports (in Local Currency Unit) in India in 1990 to that in 1992?
Give a very brief answer. 0.6. What is the ratio of the Exports (in Local Currency Unit) in Peru in 1990 to that in 1992?
Provide a succinct answer. 0.15. What is the ratio of the Exports (in Local Currency Unit) in United States in 1990 to that in 1992?
Give a very brief answer. 0.87. What is the ratio of the Exports (in Local Currency Unit) in Guinea in 1990 to that in 1993?
Your answer should be very brief. 0.66. What is the ratio of the Exports (in Local Currency Unit) in India in 1990 to that in 1993?
Ensure brevity in your answer.  0.47. What is the ratio of the Exports (in Local Currency Unit) in Peru in 1990 to that in 1993?
Make the answer very short. 0.1. What is the ratio of the Exports (in Local Currency Unit) in United States in 1990 to that in 1993?
Provide a short and direct response. 0.84. What is the ratio of the Exports (in Local Currency Unit) in Guinea in 1990 to that in 1994?
Make the answer very short. 0.73. What is the ratio of the Exports (in Local Currency Unit) in India in 1990 to that in 1994?
Provide a succinct answer. 0.4. What is the ratio of the Exports (in Local Currency Unit) in Peru in 1990 to that in 1994?
Provide a short and direct response. 0.07. What is the ratio of the Exports (in Local Currency Unit) of United States in 1990 to that in 1994?
Offer a terse response. 0.77. What is the ratio of the Exports (in Local Currency Unit) in Guinea in 1990 to that in 1995?
Your answer should be compact. 0.71. What is the ratio of the Exports (in Local Currency Unit) in India in 1990 to that in 1995?
Provide a short and direct response. 0.31. What is the ratio of the Exports (in Local Currency Unit) of Peru in 1990 to that in 1995?
Offer a very short reply. 0.06. What is the ratio of the Exports (in Local Currency Unit) of United States in 1990 to that in 1995?
Provide a short and direct response. 0.68. What is the ratio of the Exports (in Local Currency Unit) in Guinea in 1991 to that in 1992?
Ensure brevity in your answer.  0.94. What is the ratio of the Exports (in Local Currency Unit) of India in 1991 to that in 1992?
Ensure brevity in your answer.  0.84. What is the ratio of the Exports (in Local Currency Unit) in Peru in 1991 to that in 1992?
Offer a terse response. 0.58. What is the ratio of the Exports (in Local Currency Unit) in United States in 1991 to that in 1992?
Ensure brevity in your answer.  0.94. What is the ratio of the Exports (in Local Currency Unit) of Guinea in 1991 to that in 1993?
Provide a succinct answer. 0.83. What is the ratio of the Exports (in Local Currency Unit) in India in 1991 to that in 1993?
Your answer should be very brief. 0.65. What is the ratio of the Exports (in Local Currency Unit) of Peru in 1991 to that in 1993?
Your answer should be compact. 0.38. What is the ratio of the Exports (in Local Currency Unit) in United States in 1991 to that in 1993?
Your answer should be compact. 0.91. What is the ratio of the Exports (in Local Currency Unit) of Guinea in 1991 to that in 1994?
Your answer should be compact. 0.92. What is the ratio of the Exports (in Local Currency Unit) in India in 1991 to that in 1994?
Provide a succinct answer. 0.55. What is the ratio of the Exports (in Local Currency Unit) in Peru in 1991 to that in 1994?
Your answer should be very brief. 0.26. What is the ratio of the Exports (in Local Currency Unit) in United States in 1991 to that in 1994?
Your response must be concise. 0.83. What is the ratio of the Exports (in Local Currency Unit) of Guinea in 1991 to that in 1995?
Offer a terse response. 0.89. What is the ratio of the Exports (in Local Currency Unit) of India in 1991 to that in 1995?
Provide a short and direct response. 0.43. What is the ratio of the Exports (in Local Currency Unit) in Peru in 1991 to that in 1995?
Keep it short and to the point. 0.22. What is the ratio of the Exports (in Local Currency Unit) of United States in 1991 to that in 1995?
Keep it short and to the point. 0.73. What is the ratio of the Exports (in Local Currency Unit) in Guinea in 1992 to that in 1993?
Offer a terse response. 0.89. What is the ratio of the Exports (in Local Currency Unit) in India in 1992 to that in 1993?
Provide a succinct answer. 0.78. What is the ratio of the Exports (in Local Currency Unit) of Peru in 1992 to that in 1993?
Offer a terse response. 0.65. What is the ratio of the Exports (in Local Currency Unit) in United States in 1992 to that in 1993?
Ensure brevity in your answer.  0.97. What is the ratio of the Exports (in Local Currency Unit) of Guinea in 1992 to that in 1994?
Ensure brevity in your answer.  0.98. What is the ratio of the Exports (in Local Currency Unit) of India in 1992 to that in 1994?
Make the answer very short. 0.66. What is the ratio of the Exports (in Local Currency Unit) in Peru in 1992 to that in 1994?
Provide a succinct answer. 0.45. What is the ratio of the Exports (in Local Currency Unit) in United States in 1992 to that in 1994?
Your answer should be compact. 0.88. What is the ratio of the Exports (in Local Currency Unit) in Guinea in 1992 to that in 1995?
Your answer should be compact. 0.95. What is the ratio of the Exports (in Local Currency Unit) of India in 1992 to that in 1995?
Provide a succinct answer. 0.51. What is the ratio of the Exports (in Local Currency Unit) in Peru in 1992 to that in 1995?
Ensure brevity in your answer.  0.37. What is the ratio of the Exports (in Local Currency Unit) in United States in 1992 to that in 1995?
Make the answer very short. 0.78. What is the ratio of the Exports (in Local Currency Unit) in Guinea in 1993 to that in 1994?
Offer a very short reply. 1.11. What is the ratio of the Exports (in Local Currency Unit) of India in 1993 to that in 1994?
Make the answer very short. 0.85. What is the ratio of the Exports (in Local Currency Unit) in Peru in 1993 to that in 1994?
Make the answer very short. 0.69. What is the ratio of the Exports (in Local Currency Unit) of United States in 1993 to that in 1994?
Provide a succinct answer. 0.91. What is the ratio of the Exports (in Local Currency Unit) in Guinea in 1993 to that in 1995?
Your answer should be very brief. 1.07. What is the ratio of the Exports (in Local Currency Unit) of India in 1993 to that in 1995?
Your response must be concise. 0.66. What is the ratio of the Exports (in Local Currency Unit) in Peru in 1993 to that in 1995?
Ensure brevity in your answer.  0.57. What is the ratio of the Exports (in Local Currency Unit) in United States in 1993 to that in 1995?
Make the answer very short. 0.81. What is the ratio of the Exports (in Local Currency Unit) of Guinea in 1994 to that in 1995?
Offer a terse response. 0.97. What is the ratio of the Exports (in Local Currency Unit) in India in 1994 to that in 1995?
Offer a terse response. 0.78. What is the ratio of the Exports (in Local Currency Unit) in Peru in 1994 to that in 1995?
Ensure brevity in your answer.  0.83. What is the ratio of the Exports (in Local Currency Unit) of United States in 1994 to that in 1995?
Give a very brief answer. 0.89. What is the difference between the highest and the second highest Exports (in Local Currency Unit) in Guinea?
Your answer should be compact. 5.75e+1. What is the difference between the highest and the second highest Exports (in Local Currency Unit) in India?
Ensure brevity in your answer.  2.91e+11. What is the difference between the highest and the second highest Exports (in Local Currency Unit) in Peru?
Keep it short and to the point. 2.53e+09. What is the difference between the highest and the second highest Exports (in Local Currency Unit) of United States?
Provide a succinct answer. 9.19e+1. What is the difference between the highest and the lowest Exports (in Local Currency Unit) of Guinea?
Your response must be concise. 3.83e+11. What is the difference between the highest and the lowest Exports (in Local Currency Unit) in India?
Offer a very short reply. 9.61e+11. What is the difference between the highest and the lowest Exports (in Local Currency Unit) of Peru?
Make the answer very short. 1.51e+1. What is the difference between the highest and the lowest Exports (in Local Currency Unit) of United States?
Your answer should be very brief. 3.09e+11. 